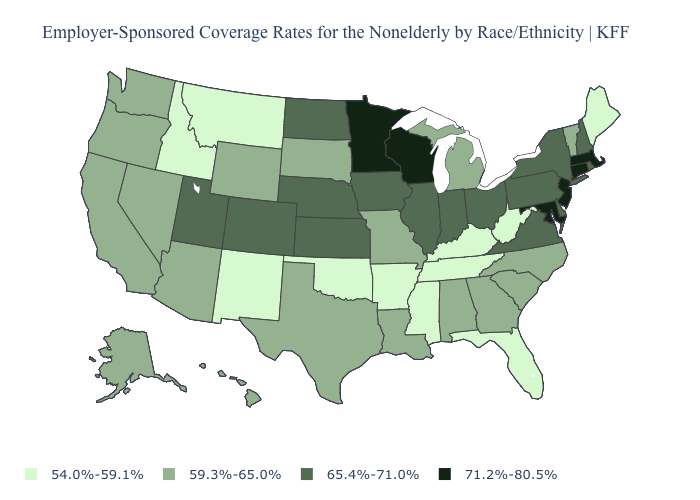Name the states that have a value in the range 71.2%-80.5%?
Be succinct. Connecticut, Maryland, Massachusetts, Minnesota, New Jersey, Wisconsin. What is the value of Florida?
Short answer required. 54.0%-59.1%. Which states have the lowest value in the USA?
Concise answer only. Arkansas, Florida, Idaho, Kentucky, Maine, Mississippi, Montana, New Mexico, Oklahoma, Tennessee, West Virginia. Is the legend a continuous bar?
Quick response, please. No. Does Iowa have a higher value than Connecticut?
Keep it brief. No. Which states have the lowest value in the USA?
Answer briefly. Arkansas, Florida, Idaho, Kentucky, Maine, Mississippi, Montana, New Mexico, Oklahoma, Tennessee, West Virginia. How many symbols are there in the legend?
Be succinct. 4. Which states have the lowest value in the South?
Quick response, please. Arkansas, Florida, Kentucky, Mississippi, Oklahoma, Tennessee, West Virginia. Does Illinois have the same value as Utah?
Answer briefly. Yes. What is the lowest value in states that border Louisiana?
Give a very brief answer. 54.0%-59.1%. Name the states that have a value in the range 59.3%-65.0%?
Be succinct. Alabama, Alaska, Arizona, California, Georgia, Hawaii, Louisiana, Michigan, Missouri, Nevada, North Carolina, Oregon, South Carolina, South Dakota, Texas, Vermont, Washington, Wyoming. Does Idaho have the same value as Florida?
Keep it brief. Yes. What is the lowest value in states that border Nevada?
Answer briefly. 54.0%-59.1%. What is the value of Minnesota?
Keep it brief. 71.2%-80.5%. What is the value of New Hampshire?
Answer briefly. 65.4%-71.0%. 